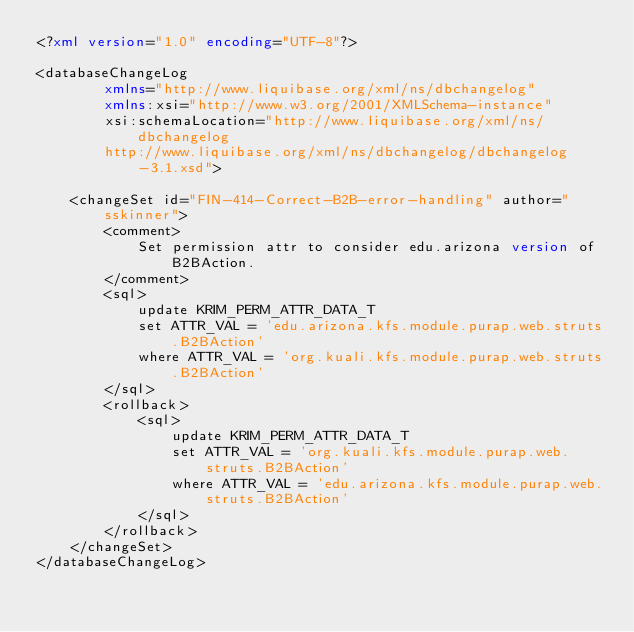Convert code to text. <code><loc_0><loc_0><loc_500><loc_500><_XML_><?xml version="1.0" encoding="UTF-8"?>

<databaseChangeLog
        xmlns="http://www.liquibase.org/xml/ns/dbchangelog"
        xmlns:xsi="http://www.w3.org/2001/XMLSchema-instance"
        xsi:schemaLocation="http://www.liquibase.org/xml/ns/dbchangelog
        http://www.liquibase.org/xml/ns/dbchangelog/dbchangelog-3.1.xsd">

    <changeSet id="FIN-414-Correct-B2B-error-handling" author="sskinner">
        <comment>
            Set permission attr to consider edu.arizona version of B2BAction.
        </comment>
        <sql>
            update KRIM_PERM_ATTR_DATA_T
            set ATTR_VAL = 'edu.arizona.kfs.module.purap.web.struts.B2BAction'
            where ATTR_VAL = 'org.kuali.kfs.module.purap.web.struts.B2BAction'
        </sql>
        <rollback>
            <sql>
                update KRIM_PERM_ATTR_DATA_T
                set ATTR_VAL = 'org.kuali.kfs.module.purap.web.struts.B2BAction'
                where ATTR_VAL = 'edu.arizona.kfs.module.purap.web.struts.B2BAction'
            </sql>
        </rollback>
    </changeSet>
</databaseChangeLog>
</code> 